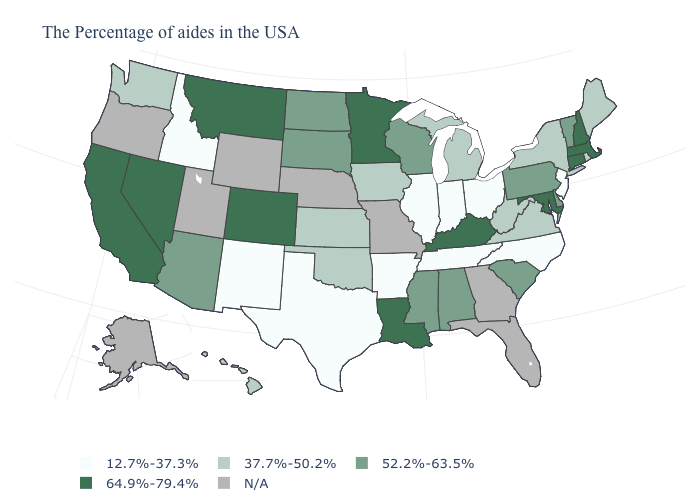Is the legend a continuous bar?
Quick response, please. No. What is the value of Arizona?
Write a very short answer. 52.2%-63.5%. Name the states that have a value in the range 52.2%-63.5%?
Write a very short answer. Vermont, Delaware, Pennsylvania, South Carolina, Alabama, Wisconsin, Mississippi, South Dakota, North Dakota, Arizona. Name the states that have a value in the range N/A?
Quick response, please. Florida, Georgia, Missouri, Nebraska, Wyoming, Utah, Oregon, Alaska. Name the states that have a value in the range N/A?
Write a very short answer. Florida, Georgia, Missouri, Nebraska, Wyoming, Utah, Oregon, Alaska. Name the states that have a value in the range 52.2%-63.5%?
Concise answer only. Vermont, Delaware, Pennsylvania, South Carolina, Alabama, Wisconsin, Mississippi, South Dakota, North Dakota, Arizona. Does the first symbol in the legend represent the smallest category?
Concise answer only. Yes. Does the first symbol in the legend represent the smallest category?
Be succinct. Yes. Does Texas have the lowest value in the South?
Short answer required. Yes. What is the highest value in states that border Iowa?
Keep it brief. 64.9%-79.4%. Is the legend a continuous bar?
Short answer required. No. Name the states that have a value in the range 12.7%-37.3%?
Quick response, please. New Jersey, North Carolina, Ohio, Indiana, Tennessee, Illinois, Arkansas, Texas, New Mexico, Idaho. Which states hav the highest value in the West?
Give a very brief answer. Colorado, Montana, Nevada, California. What is the value of Massachusetts?
Write a very short answer. 64.9%-79.4%. What is the value of Washington?
Answer briefly. 37.7%-50.2%. 